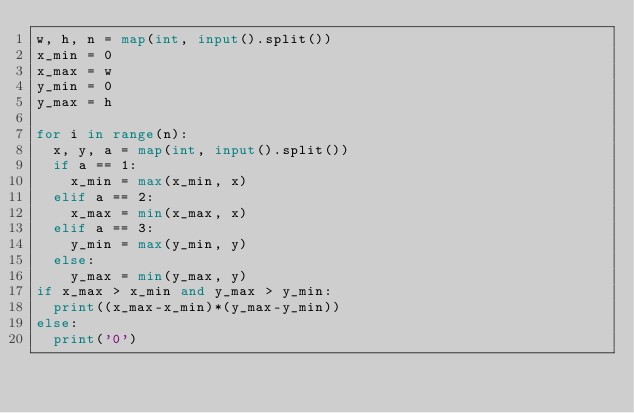<code> <loc_0><loc_0><loc_500><loc_500><_Python_>w, h, n = map(int, input().split())
x_min = 0
x_max = w
y_min = 0
y_max = h

for i in range(n):
  x, y, a = map(int, input().split())
  if a == 1:
    x_min = max(x_min, x)
  elif a == 2:
    x_max = min(x_max, x)
  elif a == 3:
    y_min = max(y_min, y)
  else:
    y_max = min(y_max, y)
if x_max > x_min and y_max > y_min:
  print((x_max-x_min)*(y_max-y_min))
else:
  print('0')</code> 